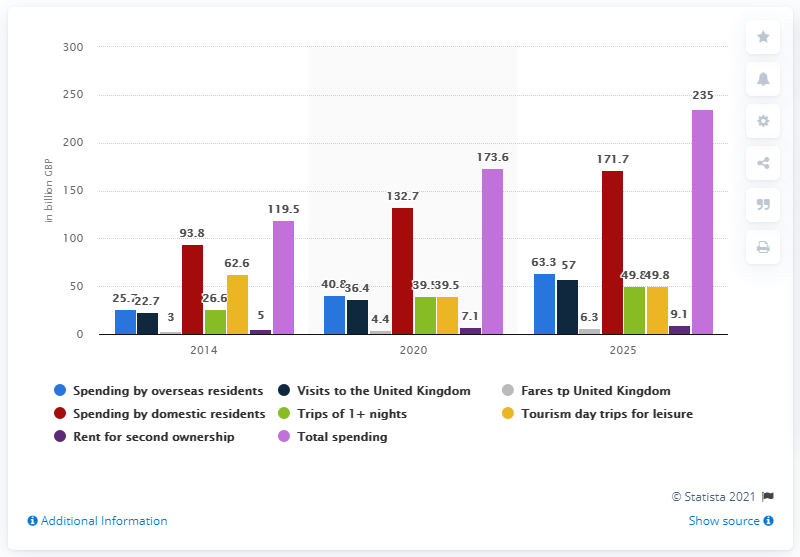Specify some key components in this picture. It is estimated that by 2020, domestic residents in the UK will have spent approximately 132.7 billion pounds. 